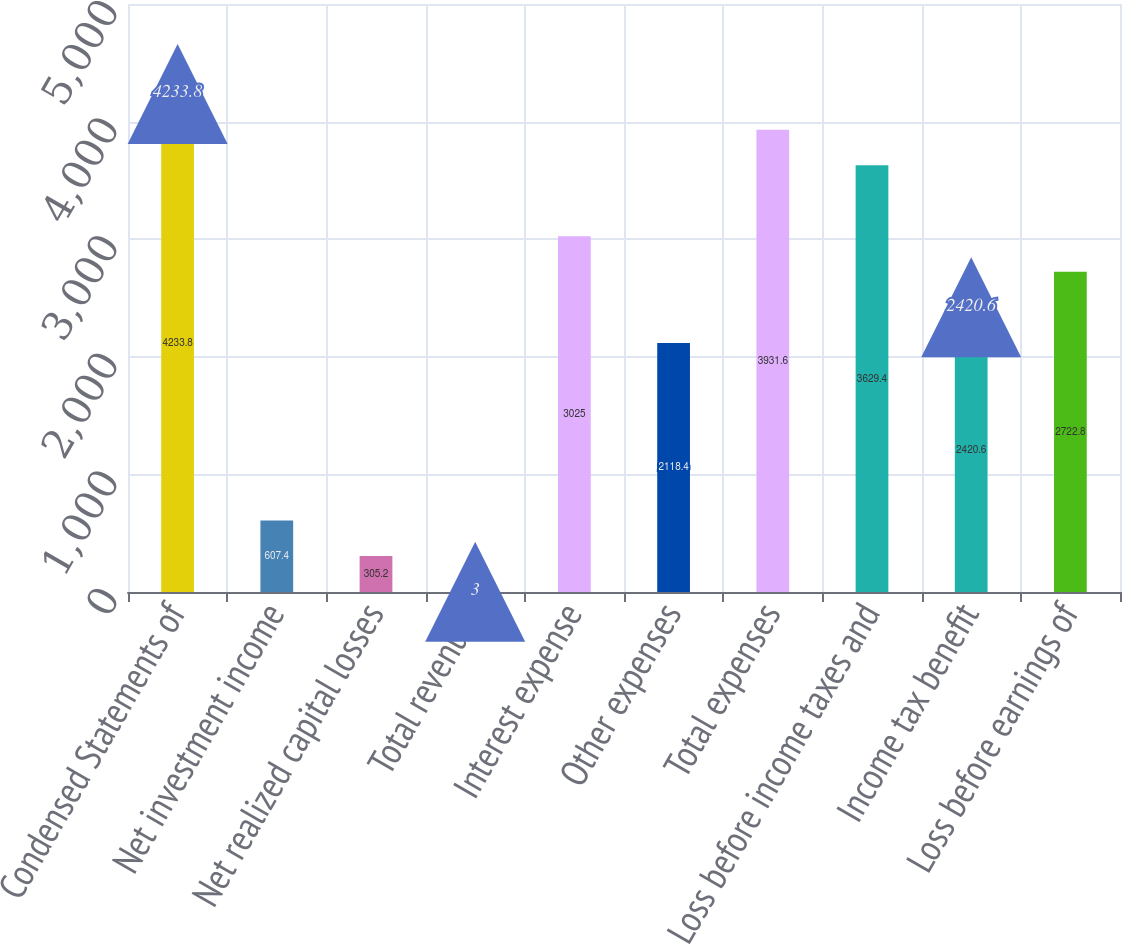<chart> <loc_0><loc_0><loc_500><loc_500><bar_chart><fcel>Condensed Statements of<fcel>Net investment income<fcel>Net realized capital losses<fcel>Total revenues<fcel>Interest expense<fcel>Other expenses<fcel>Total expenses<fcel>Loss before income taxes and<fcel>Income tax benefit<fcel>Loss before earnings of<nl><fcel>4233.8<fcel>607.4<fcel>305.2<fcel>3<fcel>3025<fcel>2118.4<fcel>3931.6<fcel>3629.4<fcel>2420.6<fcel>2722.8<nl></chart> 